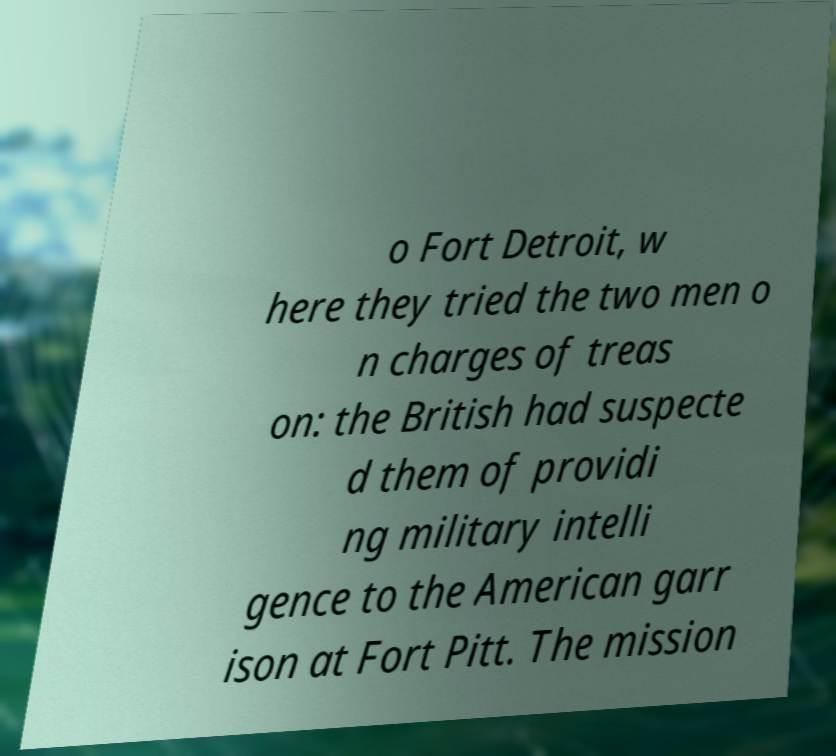Could you extract and type out the text from this image? o Fort Detroit, w here they tried the two men o n charges of treas on: the British had suspecte d them of providi ng military intelli gence to the American garr ison at Fort Pitt. The mission 